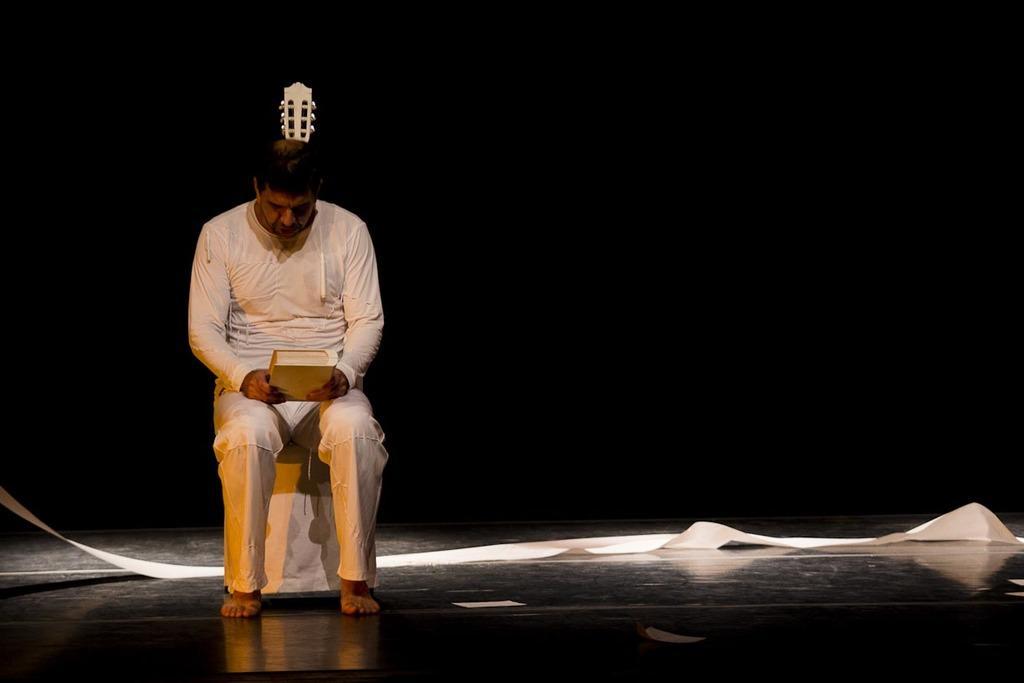Please provide a concise description of this image. The man in white T-shirt and white pant is sitting on the chairs. He is holding a book in his hands. Behind him, we see a white color thing. In the background, it is black in color. This picture is clicked in the dark. 